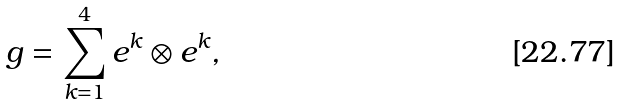<formula> <loc_0><loc_0><loc_500><loc_500>g = \sum _ { k = 1 } ^ { 4 } e ^ { k } \otimes e ^ { k } ,</formula> 